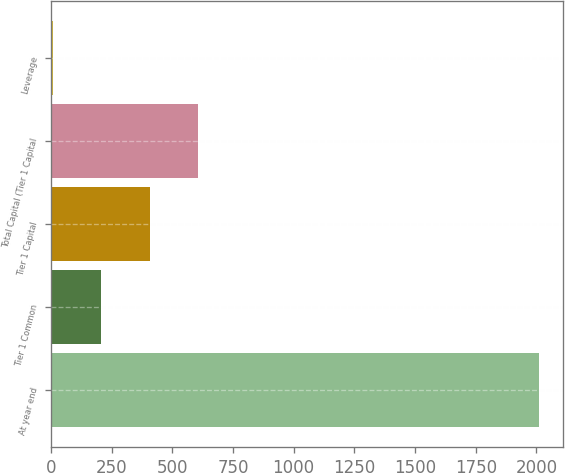Convert chart. <chart><loc_0><loc_0><loc_500><loc_500><bar_chart><fcel>At year end<fcel>Tier 1 Common<fcel>Tier 1 Capital<fcel>Total Capital (Tier 1 Capital<fcel>Leverage<nl><fcel>2009<fcel>207.1<fcel>407.31<fcel>607.52<fcel>6.89<nl></chart> 